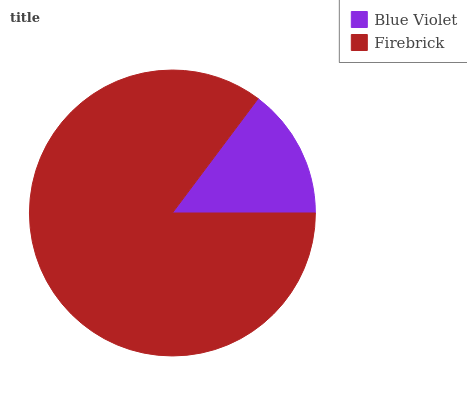Is Blue Violet the minimum?
Answer yes or no. Yes. Is Firebrick the maximum?
Answer yes or no. Yes. Is Firebrick the minimum?
Answer yes or no. No. Is Firebrick greater than Blue Violet?
Answer yes or no. Yes. Is Blue Violet less than Firebrick?
Answer yes or no. Yes. Is Blue Violet greater than Firebrick?
Answer yes or no. No. Is Firebrick less than Blue Violet?
Answer yes or no. No. Is Firebrick the high median?
Answer yes or no. Yes. Is Blue Violet the low median?
Answer yes or no. Yes. Is Blue Violet the high median?
Answer yes or no. No. Is Firebrick the low median?
Answer yes or no. No. 